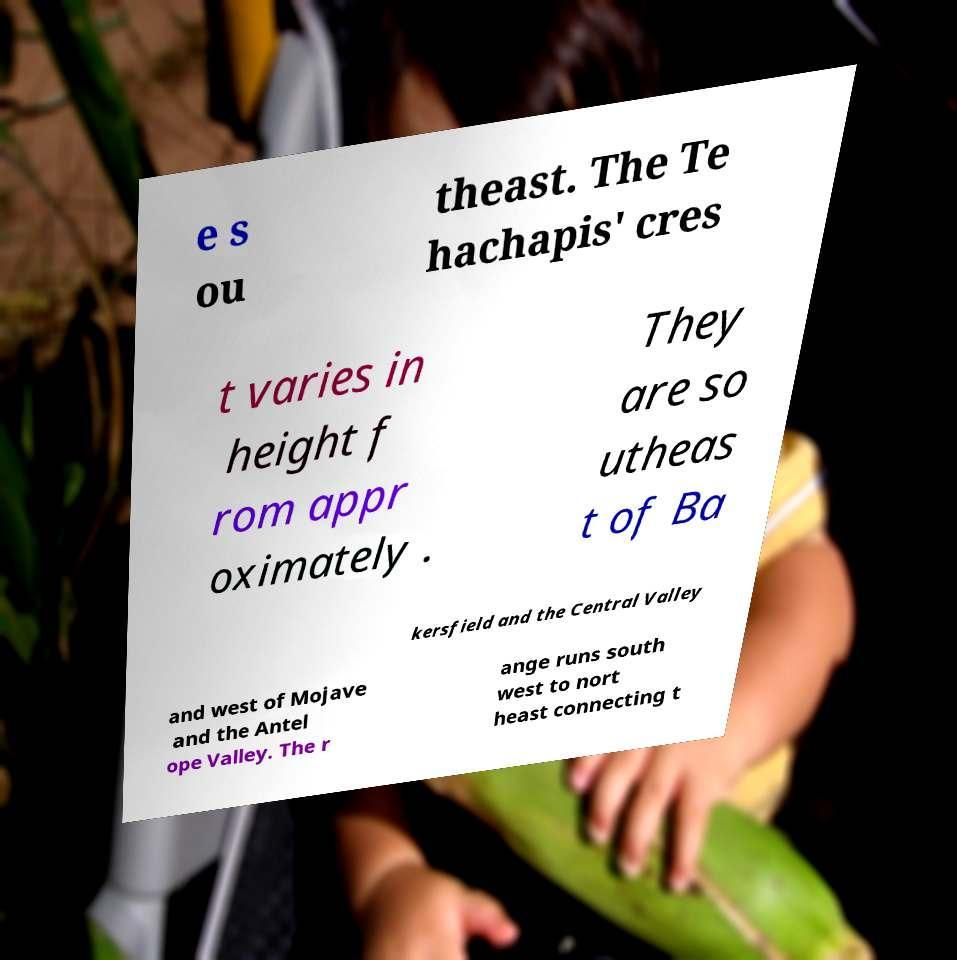Can you accurately transcribe the text from the provided image for me? e s ou theast. The Te hachapis' cres t varies in height f rom appr oximately . They are so utheas t of Ba kersfield and the Central Valley and west of Mojave and the Antel ope Valley. The r ange runs south west to nort heast connecting t 